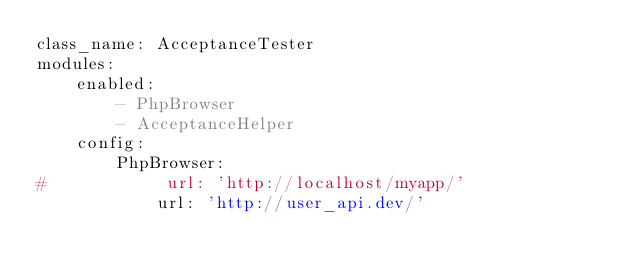<code> <loc_0><loc_0><loc_500><loc_500><_YAML_>class_name: AcceptanceTester
modules:
    enabled:
        - PhpBrowser
        - AcceptanceHelper
    config:
        PhpBrowser:
#            url: 'http://localhost/myapp/'
            url: 'http://user_api.dev/'
</code> 